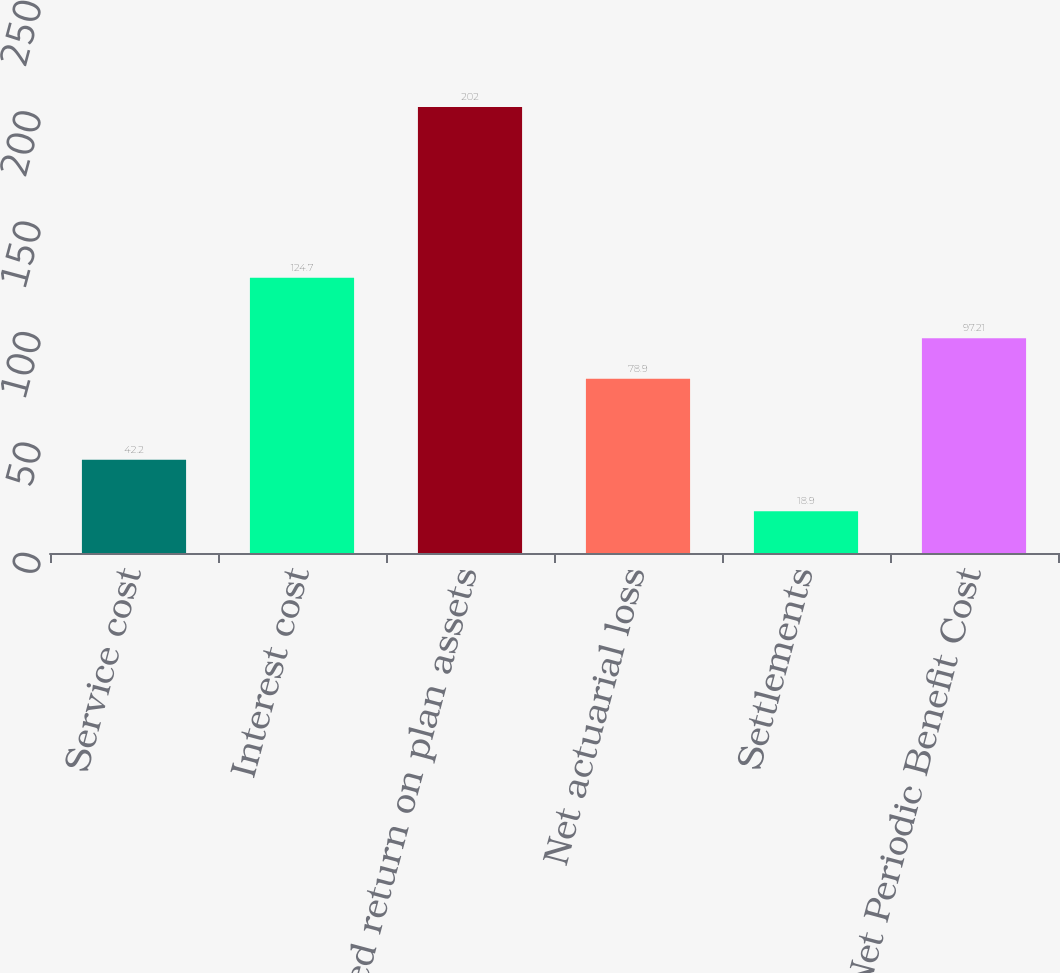Convert chart. <chart><loc_0><loc_0><loc_500><loc_500><bar_chart><fcel>Service cost<fcel>Interest cost<fcel>Expected return on plan assets<fcel>Net actuarial loss<fcel>Settlements<fcel>Net Periodic Benefit Cost<nl><fcel>42.2<fcel>124.7<fcel>202<fcel>78.9<fcel>18.9<fcel>97.21<nl></chart> 